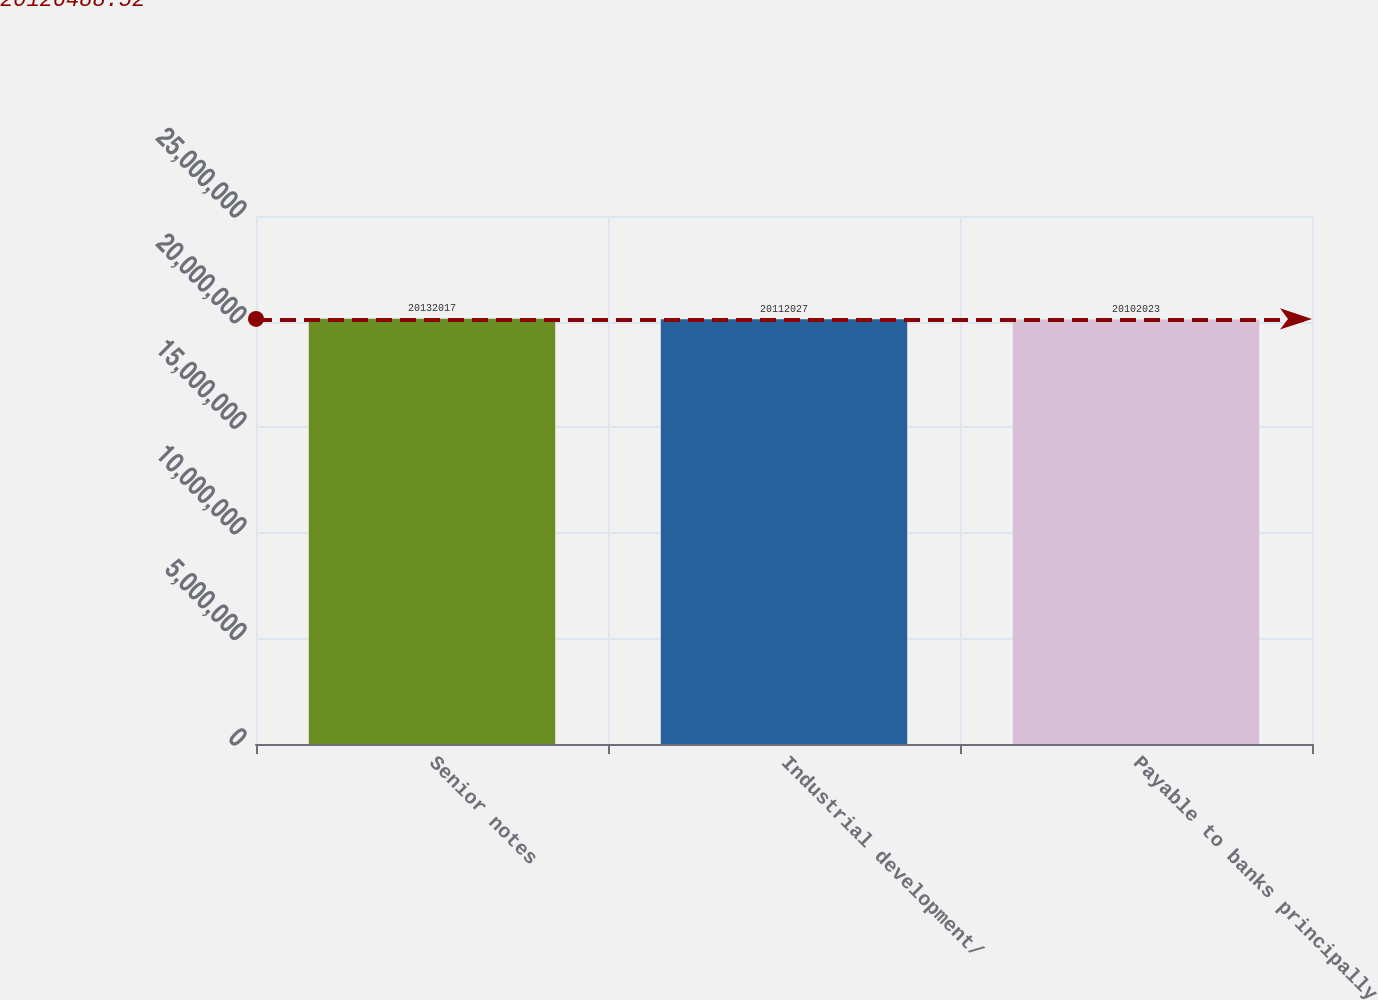Convert chart to OTSL. <chart><loc_0><loc_0><loc_500><loc_500><bar_chart><fcel>Senior notes<fcel>Industrial development/<fcel>Payable to banks principally<nl><fcel>2.0132e+07<fcel>2.0112e+07<fcel>2.0102e+07<nl></chart> 